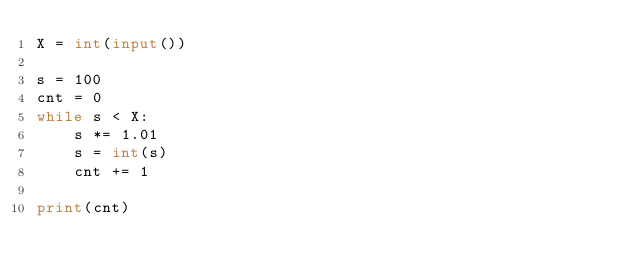Convert code to text. <code><loc_0><loc_0><loc_500><loc_500><_Python_>X = int(input())

s = 100
cnt = 0
while s < X:
    s *= 1.01
    s = int(s)
    cnt += 1

print(cnt)
</code> 